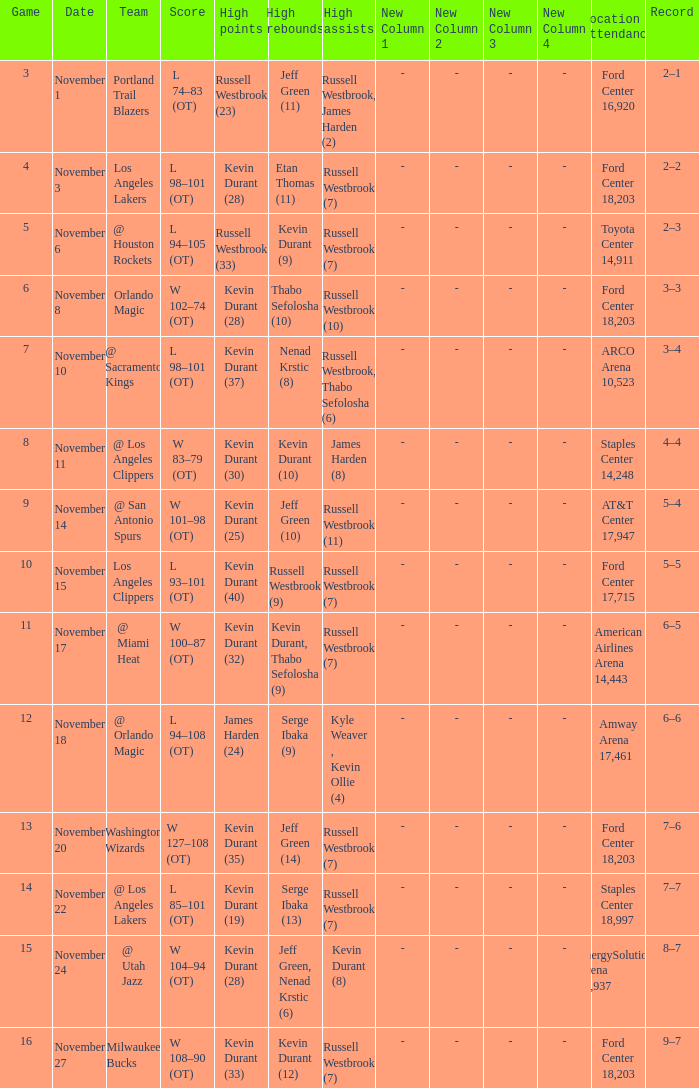Can you parse all the data within this table? {'header': ['Game', 'Date', 'Team', 'Score', 'High points', 'High rebounds', 'High assists', 'New Column 1', 'New Column 2', 'New Column 3', 'New Column 4', 'Location Attendance', 'Record'], 'rows': [['3', 'November 1', 'Portland Trail Blazers', 'L 74–83 (OT)', 'Russell Westbrook (23)', 'Jeff Green (11)', 'Russell Westbrook, James Harden (2)', '-', '-', '-', '-', 'Ford Center 16,920', '2–1'], ['4', 'November 3', 'Los Angeles Lakers', 'L 98–101 (OT)', 'Kevin Durant (28)', 'Etan Thomas (11)', 'Russell Westbrook (7)', '-', '-', '-', '-', 'Ford Center 18,203', '2–2'], ['5', 'November 6', '@ Houston Rockets', 'L 94–105 (OT)', 'Russell Westbrook (33)', 'Kevin Durant (9)', 'Russell Westbrook (7)', '-', '-', '-', '-', 'Toyota Center 14,911', '2–3'], ['6', 'November 8', 'Orlando Magic', 'W 102–74 (OT)', 'Kevin Durant (28)', 'Thabo Sefolosha (10)', 'Russell Westbrook (10)', '-', '-', '-', '-', 'Ford Center 18,203', '3–3'], ['7', 'November 10', '@ Sacramento Kings', 'L 98–101 (OT)', 'Kevin Durant (37)', 'Nenad Krstic (8)', 'Russell Westbrook, Thabo Sefolosha (6)', '-', '-', '-', '-', 'ARCO Arena 10,523', '3–4'], ['8', 'November 11', '@ Los Angeles Clippers', 'W 83–79 (OT)', 'Kevin Durant (30)', 'Kevin Durant (10)', 'James Harden (8)', '-', '-', '-', '-', 'Staples Center 14,248', '4–4'], ['9', 'November 14', '@ San Antonio Spurs', 'W 101–98 (OT)', 'Kevin Durant (25)', 'Jeff Green (10)', 'Russell Westbrook (11)', '-', '-', '-', '-', 'AT&T Center 17,947', '5–4'], ['10', 'November 15', 'Los Angeles Clippers', 'L 93–101 (OT)', 'Kevin Durant (40)', 'Russell Westbrook (9)', 'Russell Westbrook (7)', '-', '-', '-', '-', 'Ford Center 17,715', '5–5'], ['11', 'November 17', '@ Miami Heat', 'W 100–87 (OT)', 'Kevin Durant (32)', 'Kevin Durant, Thabo Sefolosha (9)', 'Russell Westbrook (7)', '-', '-', '-', '-', 'American Airlines Arena 14,443', '6–5'], ['12', 'November 18', '@ Orlando Magic', 'L 94–108 (OT)', 'James Harden (24)', 'Serge Ibaka (9)', 'Kyle Weaver , Kevin Ollie (4)', '-', '-', '-', '-', 'Amway Arena 17,461', '6–6'], ['13', 'November 20', 'Washington Wizards', 'W 127–108 (OT)', 'Kevin Durant (35)', 'Jeff Green (14)', 'Russell Westbrook (7)', '-', '-', '-', '-', 'Ford Center 18,203', '7–6'], ['14', 'November 22', '@ Los Angeles Lakers', 'L 85–101 (OT)', 'Kevin Durant (19)', 'Serge Ibaka (13)', 'Russell Westbrook (7)', '-', '-', '-', '-', 'Staples Center 18,997', '7–7'], ['15', 'November 24', '@ Utah Jazz', 'W 104–94 (OT)', 'Kevin Durant (28)', 'Jeff Green, Nenad Krstic (6)', 'Kevin Durant (8)', '-', '-', '-', '-', 'EnergySolutions Arena 17,937', '8–7'], ['16', 'November 27', 'Milwaukee Bucks', 'W 108–90 (OT)', 'Kevin Durant (33)', 'Kevin Durant (12)', 'Russell Westbrook (7)', '-', '-', '-', '-', 'Ford Center 18,203', '9–7']]} Where was the game in which Kevin Durant (25) did the most high points played? AT&T Center 17,947. 